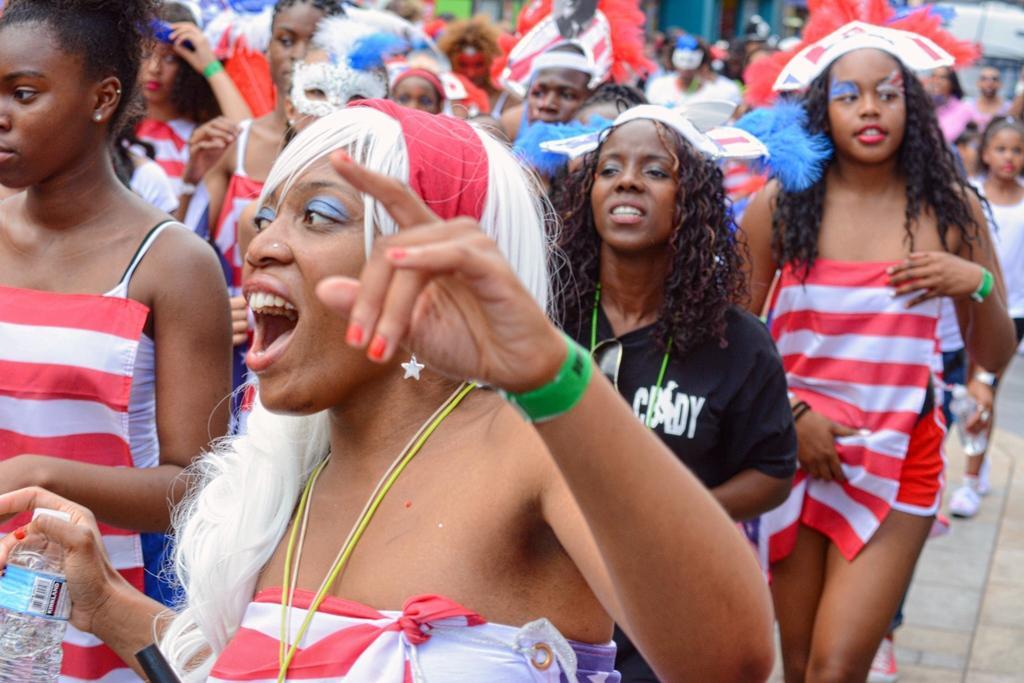Please provide a concise description of this image. In this image I can see number of persons wearing white, red and black colored dresses are standing on the ground. I can see the blurry background. 